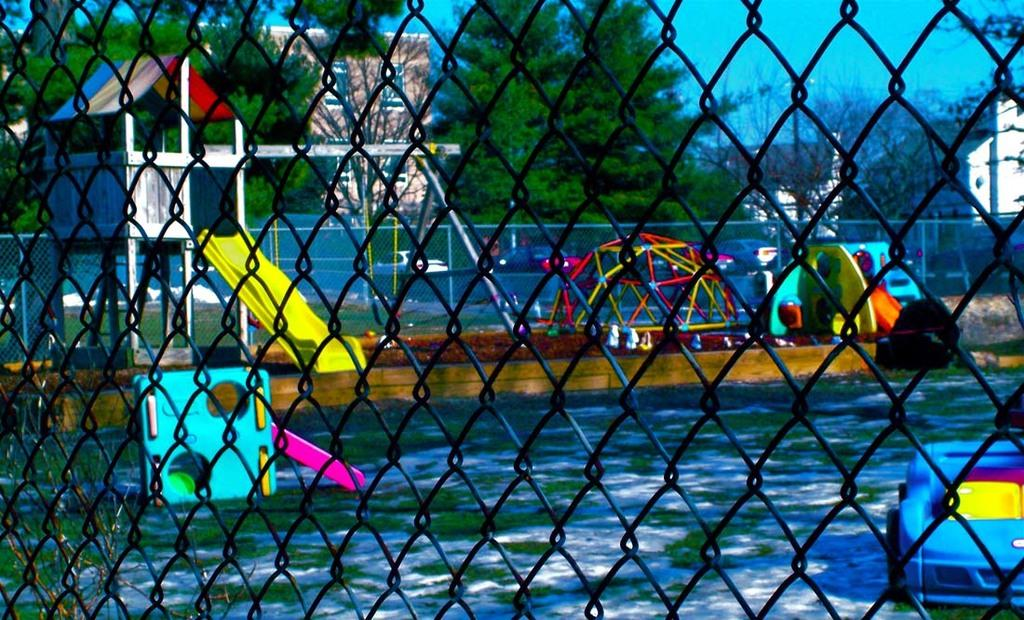What type of barrier is present in the image? There is a metal fence in the image. What type of objects are related to water in the image? There are water toys in the image. What type of playground equipment is present in the image? There is a slide in the image. What type of natural scenery can be seen in the background of the image? There are trees in the background of the image. What type of man-made structures can be seen in the background of the image? There are buildings in the background of the image. What part of the natural environment is visible in the background of the image? The sky is visible in the background of the image. What type of bead is hanging from the slide in the image? There is no bead present in the image. What type of bells can be heard ringing in the background of the image? There is no sound of bells in the image, only visual elements are described. 